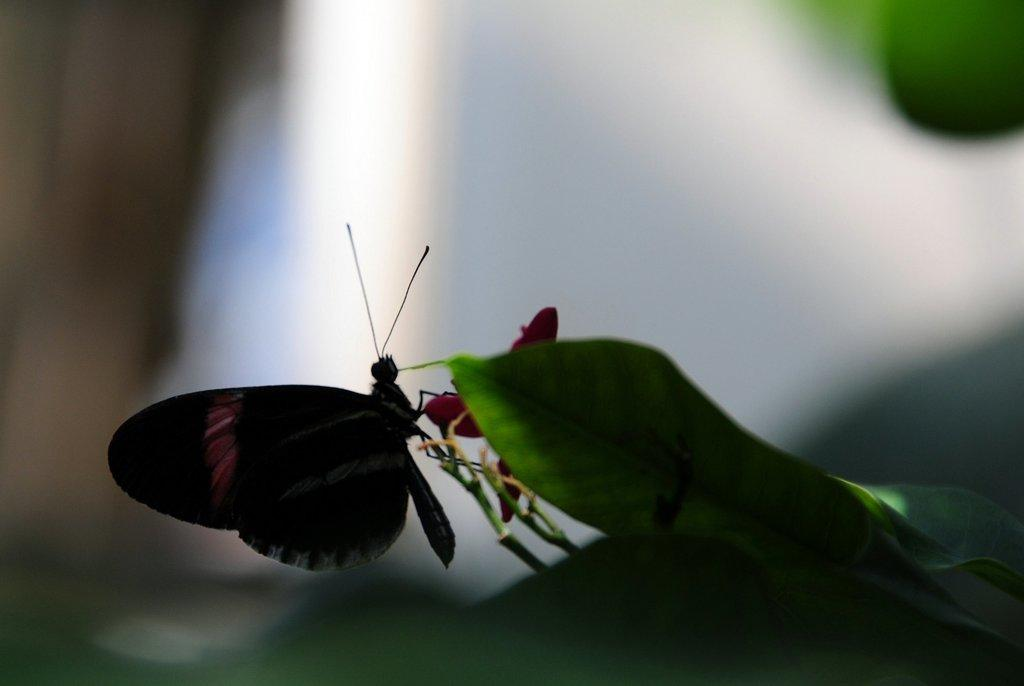What is the main subject of the image? There is a butterfly in the image. Where is the butterfly located? The butterfly is on a flower plant. What can be observed about the flower plant? The flower plant has green leaves. What type of riddle does the butterfly pose to the flower plant in the image? There is no riddle present in the image; it simply shows a butterfly on a flower plant with green leaves. 